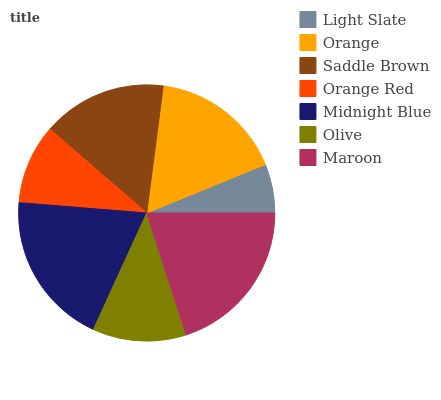Is Light Slate the minimum?
Answer yes or no. Yes. Is Maroon the maximum?
Answer yes or no. Yes. Is Orange the minimum?
Answer yes or no. No. Is Orange the maximum?
Answer yes or no. No. Is Orange greater than Light Slate?
Answer yes or no. Yes. Is Light Slate less than Orange?
Answer yes or no. Yes. Is Light Slate greater than Orange?
Answer yes or no. No. Is Orange less than Light Slate?
Answer yes or no. No. Is Saddle Brown the high median?
Answer yes or no. Yes. Is Saddle Brown the low median?
Answer yes or no. Yes. Is Olive the high median?
Answer yes or no. No. Is Orange the low median?
Answer yes or no. No. 